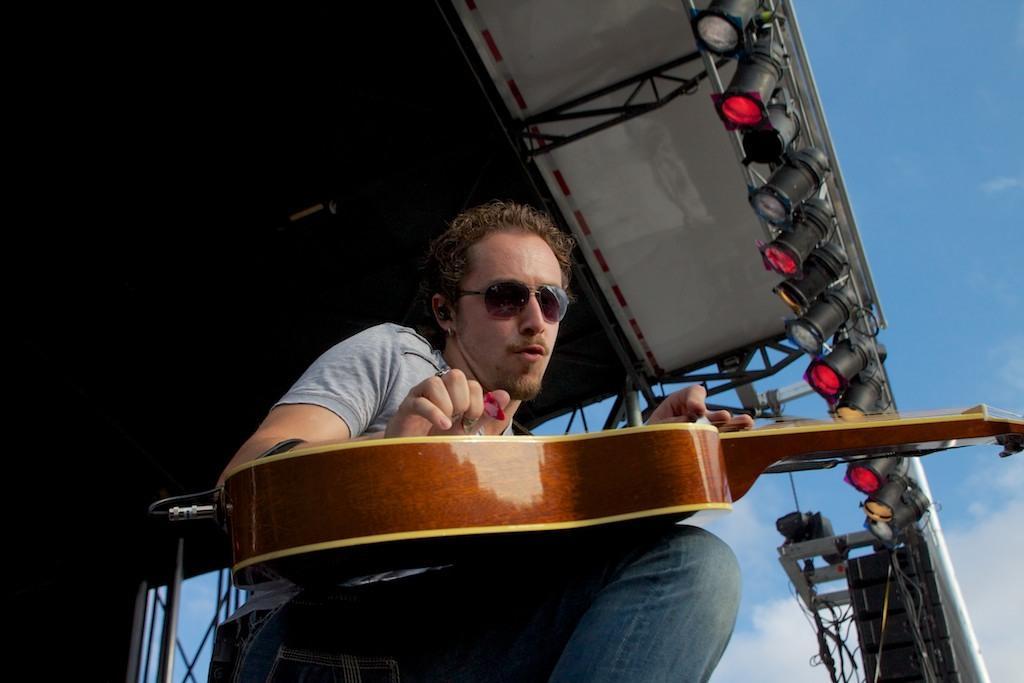Can you describe this image briefly? In this picture there is a man who is playing the guitar, by sitting on the chair and it seems to be a stage view, where there are spotlights around the area of the image at the right side, the person who is playing the guitar his wearing his sun glasses. 